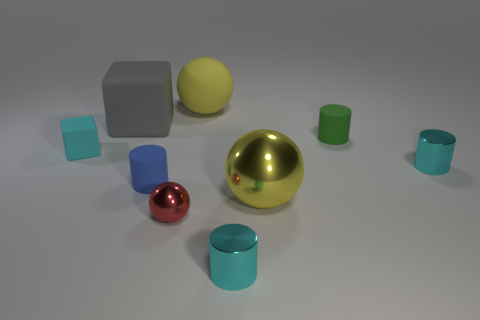Can you tell me what the large golden object is? The large golden object in the image appears to be a reflective sphere, which seems to stand out as the central figure amongst the collection of geometric shapes. 